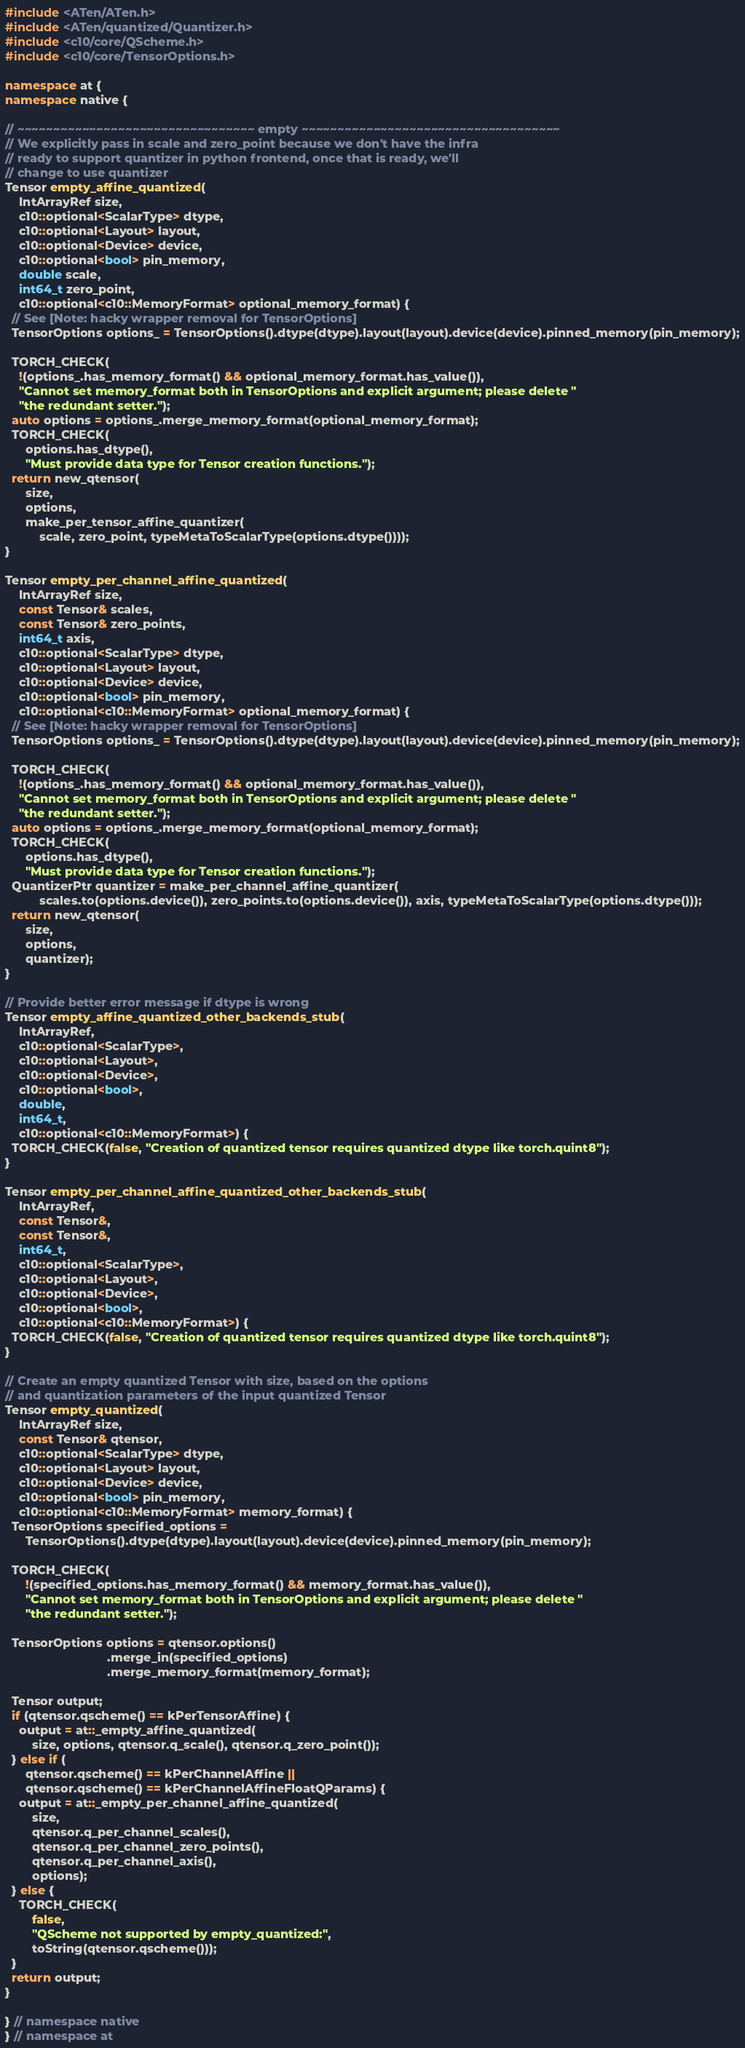Convert code to text. <code><loc_0><loc_0><loc_500><loc_500><_C++_>#include <ATen/ATen.h>
#include <ATen/quantized/Quantizer.h>
#include <c10/core/QScheme.h>
#include <c10/core/TensorOptions.h>

namespace at {
namespace native {

// ~~~~~~~~~~~~~~~~~~~~~~~~~~~~~~~~~ empty ~~~~~~~~~~~~~~~~~~~~~~~~~~~~~~~~~~~~
// We explicitly pass in scale and zero_point because we don't have the infra
// ready to support quantizer in python frontend, once that is ready, we'll
// change to use quantizer
Tensor empty_affine_quantized(
    IntArrayRef size,
    c10::optional<ScalarType> dtype,
    c10::optional<Layout> layout,
    c10::optional<Device> device,
    c10::optional<bool> pin_memory,
    double scale,
    int64_t zero_point,
    c10::optional<c10::MemoryFormat> optional_memory_format) {
  // See [Note: hacky wrapper removal for TensorOptions]
  TensorOptions options_ = TensorOptions().dtype(dtype).layout(layout).device(device).pinned_memory(pin_memory);

  TORCH_CHECK(
    !(options_.has_memory_format() && optional_memory_format.has_value()),
    "Cannot set memory_format both in TensorOptions and explicit argument; please delete "
    "the redundant setter.");
  auto options = options_.merge_memory_format(optional_memory_format);
  TORCH_CHECK(
      options.has_dtype(),
      "Must provide data type for Tensor creation functions.");
  return new_qtensor(
      size,
      options,
      make_per_tensor_affine_quantizer(
          scale, zero_point, typeMetaToScalarType(options.dtype())));
}

Tensor empty_per_channel_affine_quantized(
    IntArrayRef size,
    const Tensor& scales,
    const Tensor& zero_points,
    int64_t axis,
    c10::optional<ScalarType> dtype,
    c10::optional<Layout> layout,
    c10::optional<Device> device,
    c10::optional<bool> pin_memory,
    c10::optional<c10::MemoryFormat> optional_memory_format) {
  // See [Note: hacky wrapper removal for TensorOptions]
  TensorOptions options_ = TensorOptions().dtype(dtype).layout(layout).device(device).pinned_memory(pin_memory);

  TORCH_CHECK(
    !(options_.has_memory_format() && optional_memory_format.has_value()),
    "Cannot set memory_format both in TensorOptions and explicit argument; please delete "
    "the redundant setter.");
  auto options = options_.merge_memory_format(optional_memory_format);
  TORCH_CHECK(
      options.has_dtype(),
      "Must provide data type for Tensor creation functions.");
  QuantizerPtr quantizer = make_per_channel_affine_quantizer(
          scales.to(options.device()), zero_points.to(options.device()), axis, typeMetaToScalarType(options.dtype()));
  return new_qtensor(
      size,
      options,
      quantizer);
}

// Provide better error message if dtype is wrong
Tensor empty_affine_quantized_other_backends_stub(
    IntArrayRef,
    c10::optional<ScalarType>,
    c10::optional<Layout>,
    c10::optional<Device>,
    c10::optional<bool>,
    double,
    int64_t,
    c10::optional<c10::MemoryFormat>) {
  TORCH_CHECK(false, "Creation of quantized tensor requires quantized dtype like torch.quint8");
}

Tensor empty_per_channel_affine_quantized_other_backends_stub(
    IntArrayRef,
    const Tensor&,
    const Tensor&,
    int64_t,
    c10::optional<ScalarType>,
    c10::optional<Layout>,
    c10::optional<Device>,
    c10::optional<bool>,
    c10::optional<c10::MemoryFormat>) {
  TORCH_CHECK(false, "Creation of quantized tensor requires quantized dtype like torch.quint8");
}

// Create an empty quantized Tensor with size, based on the options
// and quantization parameters of the input quantized Tensor
Tensor empty_quantized(
    IntArrayRef size,
    const Tensor& qtensor,
    c10::optional<ScalarType> dtype,
    c10::optional<Layout> layout,
    c10::optional<Device> device,
    c10::optional<bool> pin_memory,
    c10::optional<c10::MemoryFormat> memory_format) {
  TensorOptions specified_options =
      TensorOptions().dtype(dtype).layout(layout).device(device).pinned_memory(pin_memory);

  TORCH_CHECK(
      !(specified_options.has_memory_format() && memory_format.has_value()),
      "Cannot set memory_format both in TensorOptions and explicit argument; please delete "
      "the redundant setter.");

  TensorOptions options = qtensor.options()
                              .merge_in(specified_options)
                              .merge_memory_format(memory_format);

  Tensor output;
  if (qtensor.qscheme() == kPerTensorAffine) {
    output = at::_empty_affine_quantized(
        size, options, qtensor.q_scale(), qtensor.q_zero_point());
  } else if (
      qtensor.qscheme() == kPerChannelAffine ||
      qtensor.qscheme() == kPerChannelAffineFloatQParams) {
    output = at::_empty_per_channel_affine_quantized(
        size,
        qtensor.q_per_channel_scales(),
        qtensor.q_per_channel_zero_points(),
        qtensor.q_per_channel_axis(),
        options);
  } else {
    TORCH_CHECK(
        false,
        "QScheme not supported by empty_quantized:",
        toString(qtensor.qscheme()));
  }
  return output;
}

} // namespace native
} // namespace at
</code> 